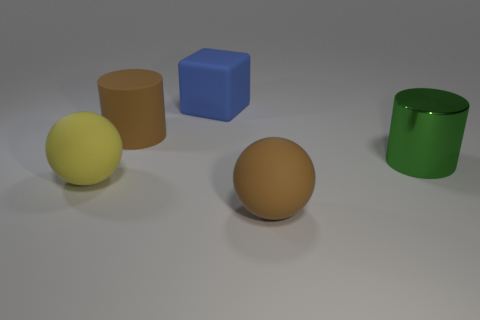What type of lighting is used in the scene? The scene appears to be lit with a diffuse global illumination, creating soft shadows and even lighting on objects, indicative of a setup meant to mimic natural light diffused through an overcast sky or indirect daylight. Does the texture of the brown sphere differ from the green cylinder's? Yes, the brown sphere has a more matte finish, diffusing light softly, while the green cylinder exhibits shinier, reflective properties, suggesting a smoother surface, possibly made of glass or polished plastic. 